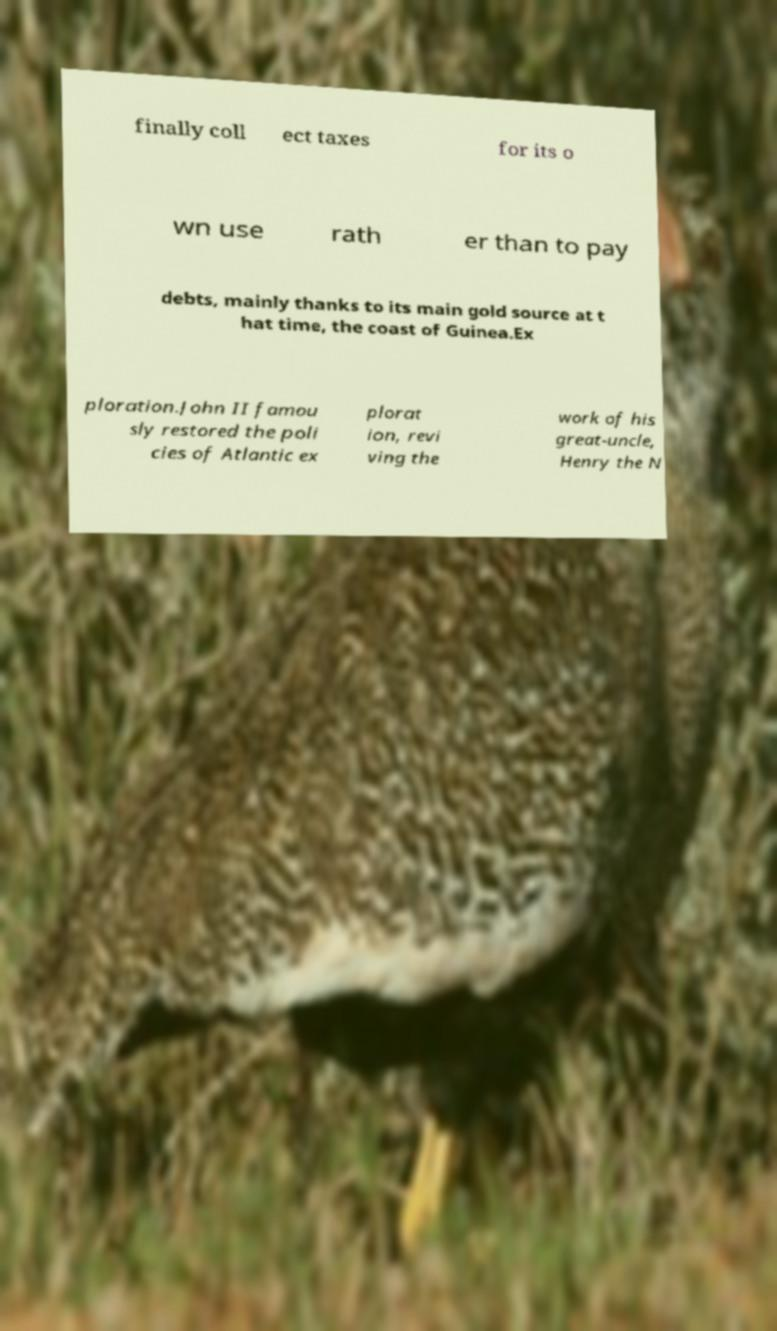Could you extract and type out the text from this image? finally coll ect taxes for its o wn use rath er than to pay debts, mainly thanks to its main gold source at t hat time, the coast of Guinea.Ex ploration.John II famou sly restored the poli cies of Atlantic ex plorat ion, revi ving the work of his great-uncle, Henry the N 